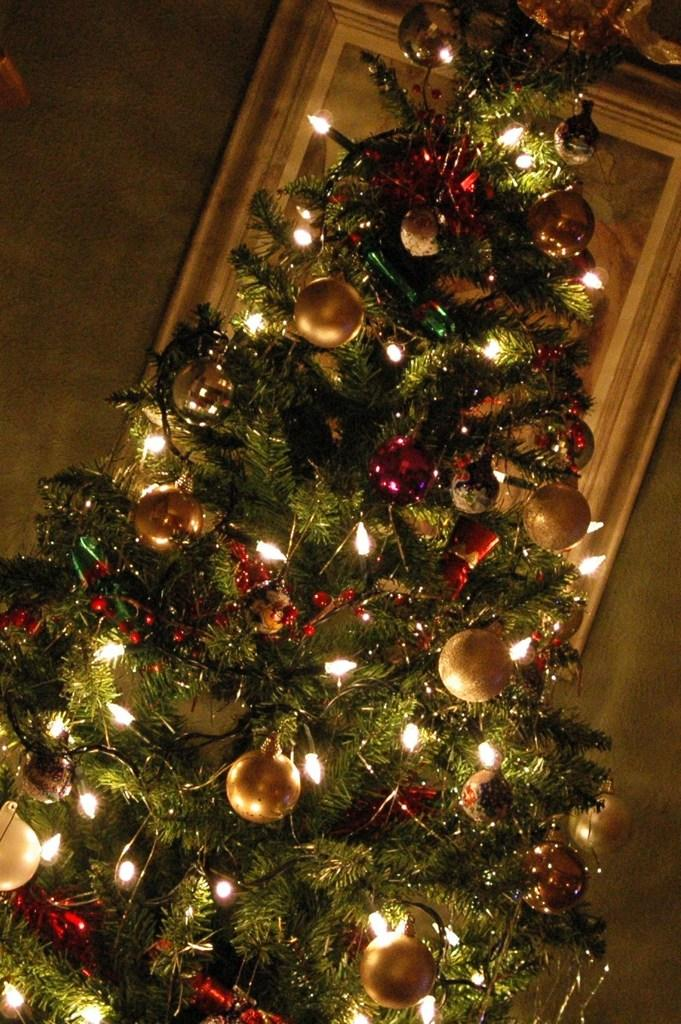What is the main object in the image? There is a Christmas tree in the image. What is a feature of the Christmas tree? The Christmas tree has lights on it. How does the glove provide comfort to the acoustics in the image? There is no glove present in the image, and therefore no impact on the acoustics can be observed. 